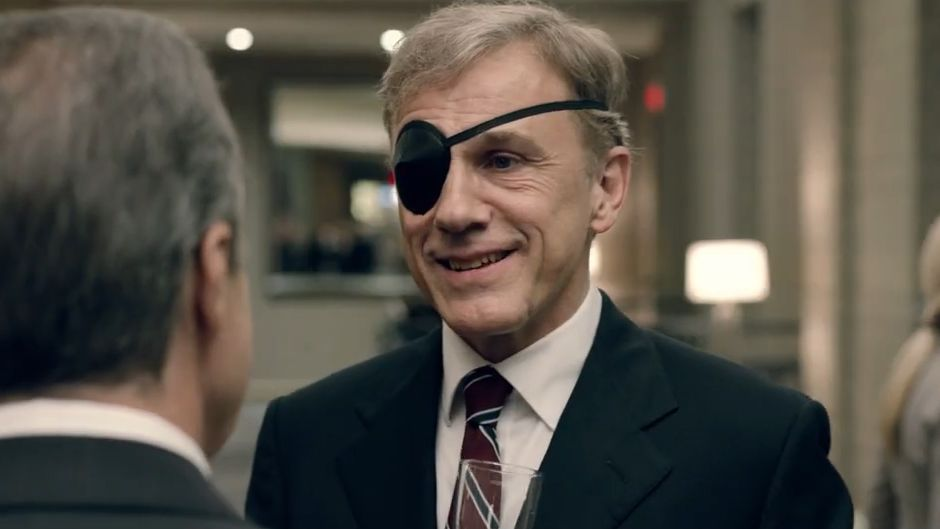What do you think about the characters' relationship based on their body language and expressions? The body language and expressions of the characters suggest a cordial and somewhat familiar relationship. Christoph Waltz’s smile and the engaged posture imply that he is enjoying the conversation. The other individual's body is slightly facing towards Waltz, indicating attentiveness and interest. This warm interaction hints that they likely share a professional connection with mutual respect, or possibly even a burgeoning friendship. 